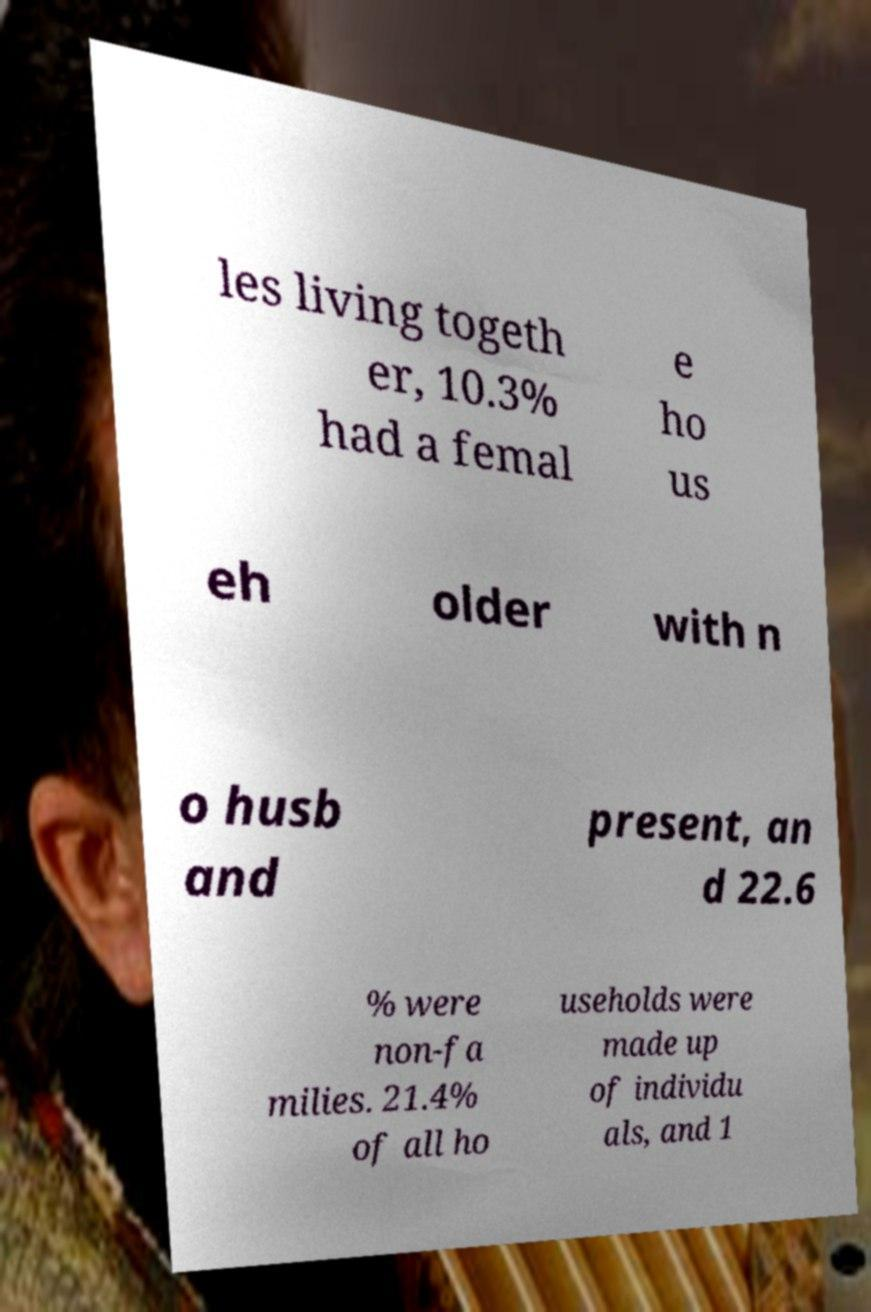I need the written content from this picture converted into text. Can you do that? les living togeth er, 10.3% had a femal e ho us eh older with n o husb and present, an d 22.6 % were non-fa milies. 21.4% of all ho useholds were made up of individu als, and 1 